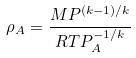Convert formula to latex. <formula><loc_0><loc_0><loc_500><loc_500>\rho _ { A } = \frac { M P ^ { ( k - 1 ) / k } } { R T P _ { A } ^ { - 1 / k } }</formula> 